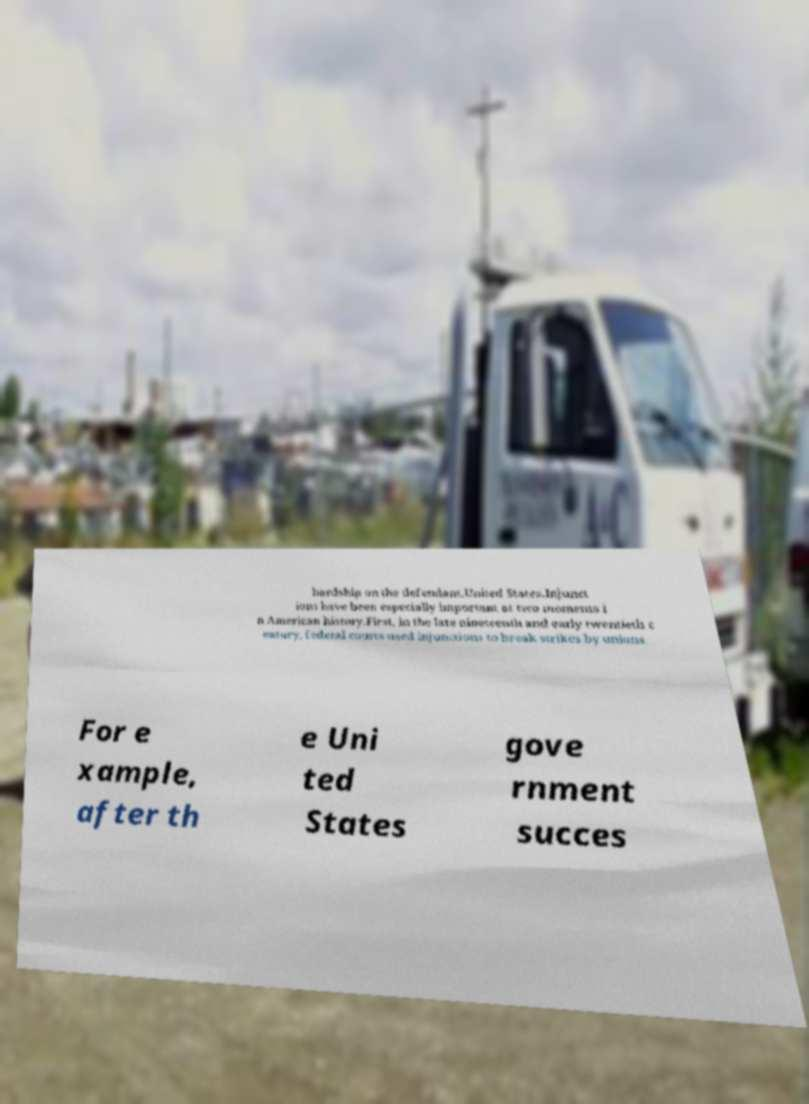Could you extract and type out the text from this image? hardship on the defendant.United States.Injunct ions have been especially important at two moments i n American history.First, in the late nineteenth and early twentieth c entury, federal courts used injunctions to break strikes by unions. For e xample, after th e Uni ted States gove rnment succes 